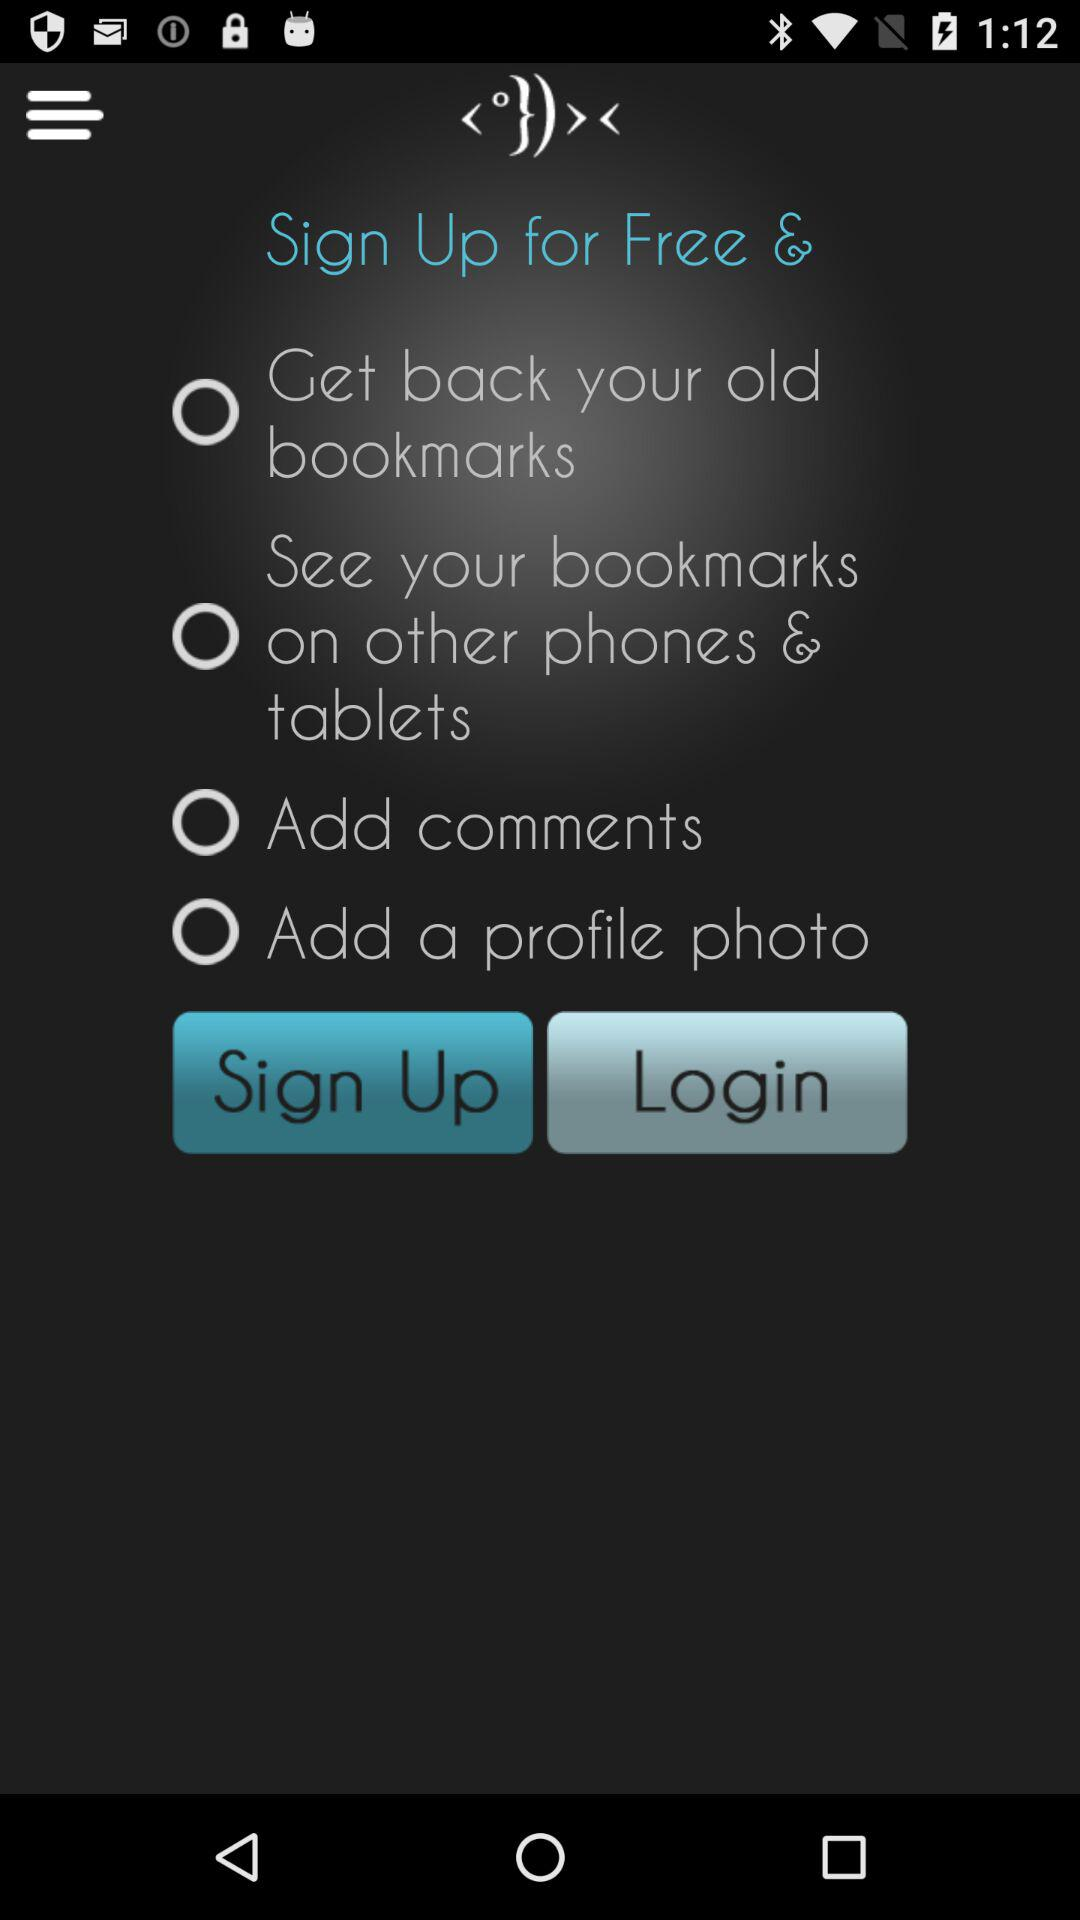Is "Add comments" selected or not? "Add comments" is not selected. 